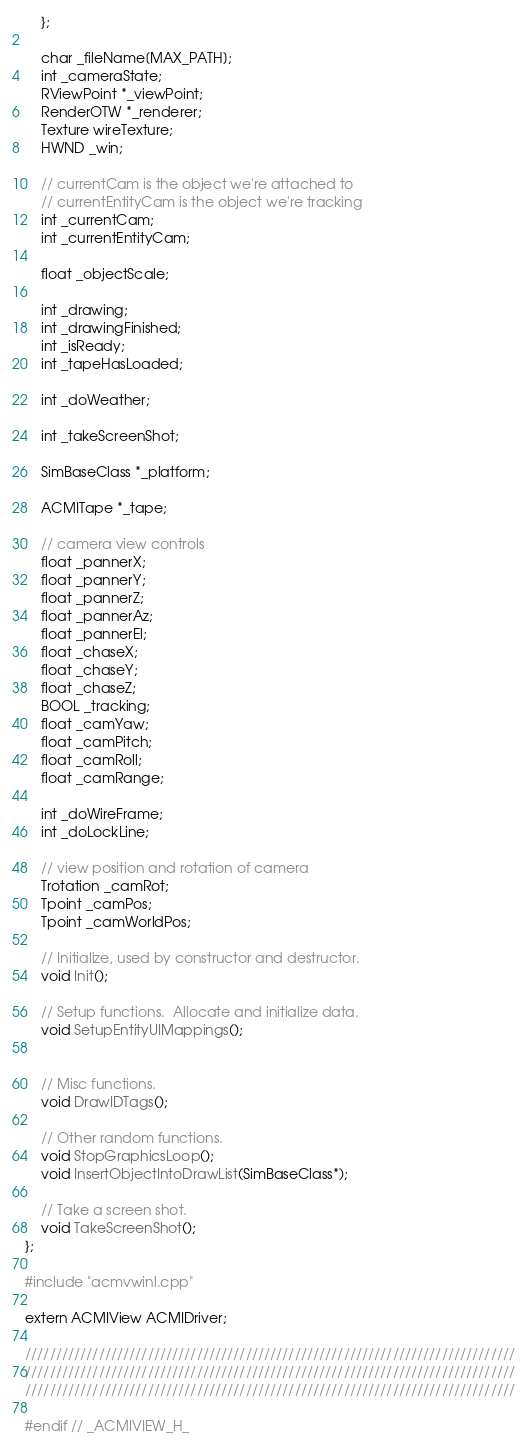Convert code to text. <code><loc_0><loc_0><loc_500><loc_500><_C_>    };

    char _fileName[MAX_PATH];
    int _cameraState;
    RViewPoint *_viewPoint;
    RenderOTW *_renderer;
    Texture wireTexture;
    HWND _win;

    // currentCam is the object we're attached to
    // currentEntityCam is the object we're tracking
    int _currentCam;
    int _currentEntityCam;

    float _objectScale;

    int _drawing;
    int _drawingFinished;
    int _isReady;
    int _tapeHasLoaded;

    int _doWeather;

    int _takeScreenShot;

    SimBaseClass *_platform;

    ACMITape *_tape;

    // camera view controls
    float _pannerX;
    float _pannerY;
    float _pannerZ;
    float _pannerAz;
    float _pannerEl;
    float _chaseX;
    float _chaseY;
    float _chaseZ;
    BOOL _tracking;
    float _camYaw;
    float _camPitch;
    float _camRoll;
    float _camRange;

    int _doWireFrame;
    int _doLockLine;

    // view position and rotation of camera
    Trotation _camRot;
    Tpoint _camPos;
    Tpoint _camWorldPos;

    // Initialize, used by constructor and destructor.
    void Init();

    // Setup functions.  Allocate and initialize data.
    void SetupEntityUIMappings();


    // Misc functions.
    void DrawIDTags();

    // Other random functions.
    void StopGraphicsLoop();
    void InsertObjectIntoDrawList(SimBaseClass*);

    // Take a screen shot.
    void TakeScreenShot();
};

#include "acmvwinl.cpp"

extern ACMIView ACMIDriver;

////////////////////////////////////////////////////////////////////////////////
////////////////////////////////////////////////////////////////////////////////
////////////////////////////////////////////////////////////////////////////////

#endif // _ACMIVIEW_H_
</code> 